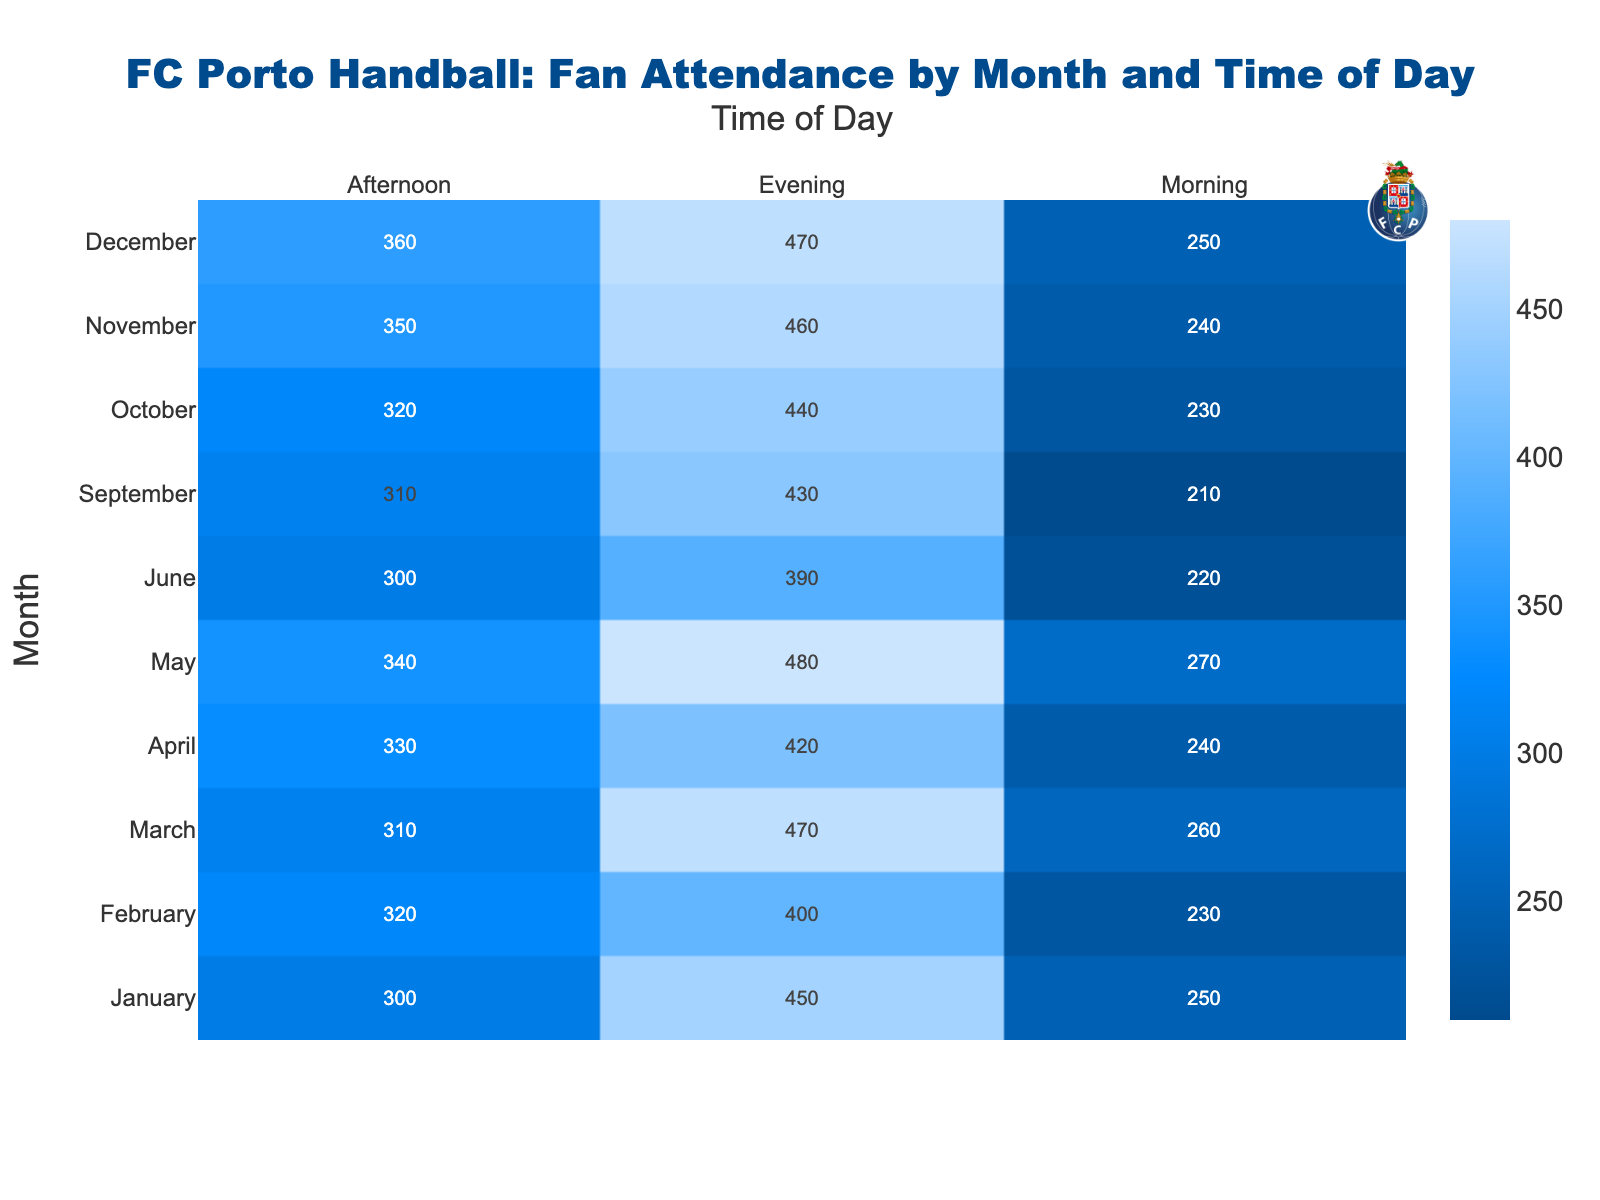What's the title of the heatmap? The title is located at the top of the heatmap and indicates the main subject of the data.
Answer: FC Porto Handball: Fan Attendance by Month and Time of Day How does fan attendance in the evening generally compare to the morning? Compare the values across the heatmap for the 'Evening' column and the 'Morning' column for all months. Notice that attendance is generally higher in the evening compared to the morning.
Answer: Higher in the evening Which month had the highest fan attendance in the afternoon? Look at the 'Afternoon' column and identify the highest value, which is in December at 360.
Answer: December What is the sum of fan attendance in November for all times of the day? Add the values for November: Morning (240) + Afternoon (350) + Evening (460) = 1050.
Answer: 1050 In which month is the fan attendance in the morning the lowest? Look at the 'Morning' row and find the lowest value, which is in September with 210.
Answer: September Compare fan attendance in January and December in the evening. Examine the 'Evening' values for January (450) and December (470). Notice which value is higher.
Answer: December What is the average fan attendance in the month of March? Calculate the average of March's values: (260 + 310 + 470) / 3 = 340.
Answer: 340 How does the morning fan attendance in April compare to that in May? Compare the numbers under 'Morning' for April (240) and May (270). Observe that May's attendance is higher.
Answer: Higher in May What is the range (difference between maximum and minimum) of fan attendance in the month of May? Identify the maximum and minimum values in May (480 in Evening and 270 in Morning) and subtract: 480 - 270 = 210.
Answer: 210 Which month had the lowest fan attendance in the evening? Look at the 'Evening' column and find the lowest value, which is in February with 400.
Answer: February 